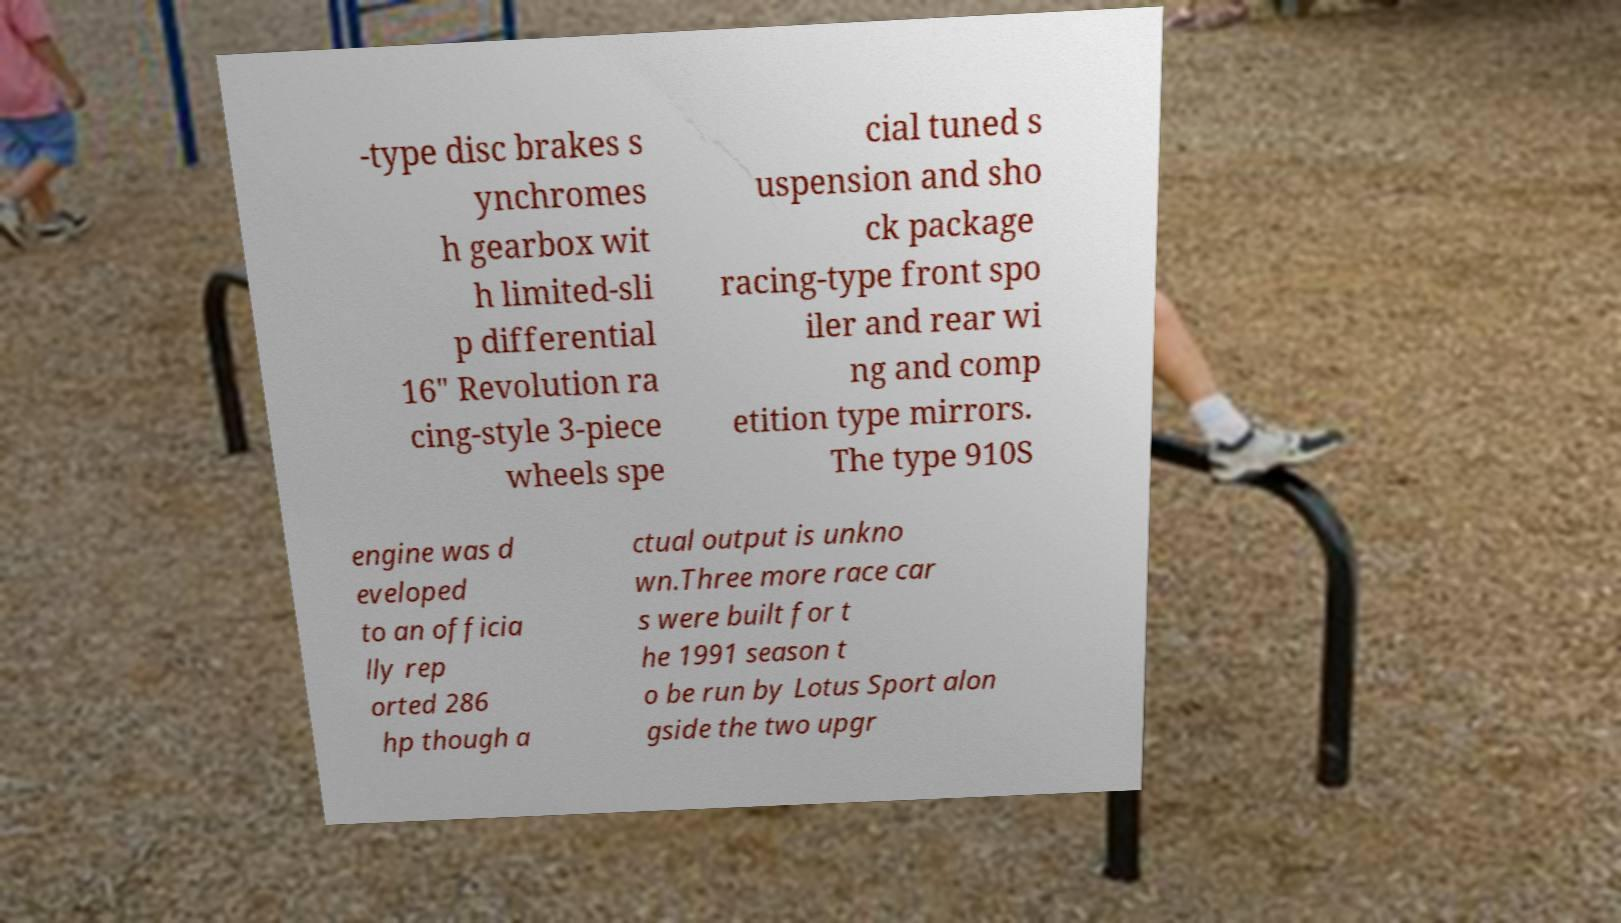Please identify and transcribe the text found in this image. -type disc brakes s ynchromes h gearbox wit h limited-sli p differential 16" Revolution ra cing-style 3-piece wheels spe cial tuned s uspension and sho ck package racing-type front spo iler and rear wi ng and comp etition type mirrors. The type 910S engine was d eveloped to an officia lly rep orted 286 hp though a ctual output is unkno wn.Three more race car s were built for t he 1991 season t o be run by Lotus Sport alon gside the two upgr 